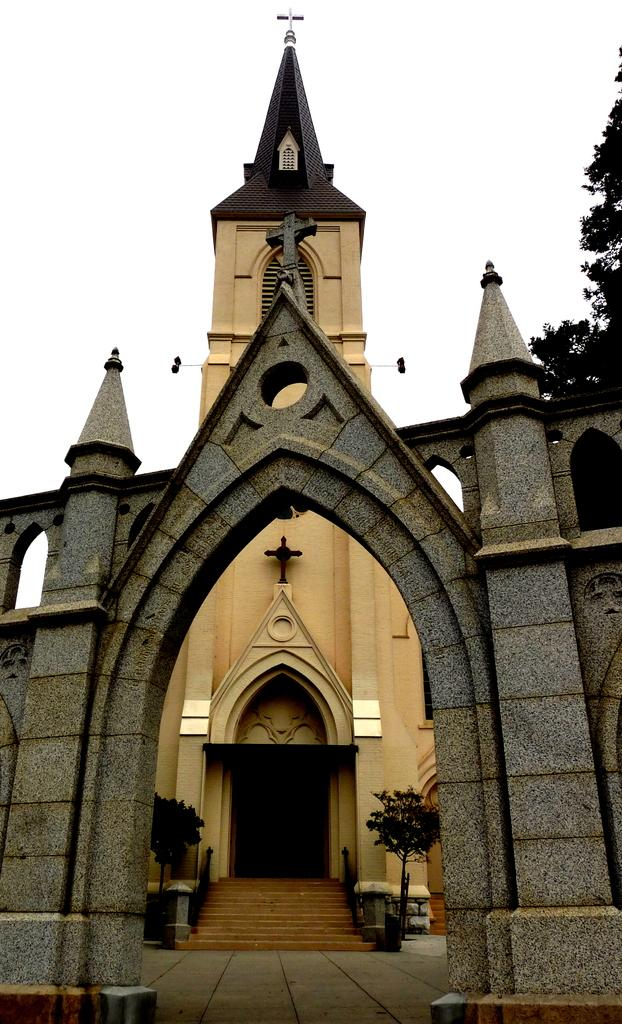What type of structure is visible in the image? There is a building in the image. What type of vegetation can be seen inside the building? There are houseplants in the image. Are there any architectural features that allow for vertical movement within the building? Yes, there are stairs in the image. Are there any safety features associated with the stairs? Yes, there are railings in the image. What type of natural environment is visible in the image? There are trees in the image. What is visible in the sky in the image? The sky is visible in the image. What type of clam is visible on the railing in the image? There are no clams present in the image; the railing is associated with the stairs in the building. What type of bells can be heard ringing in the image? There is no sound or indication of bells in the image. 